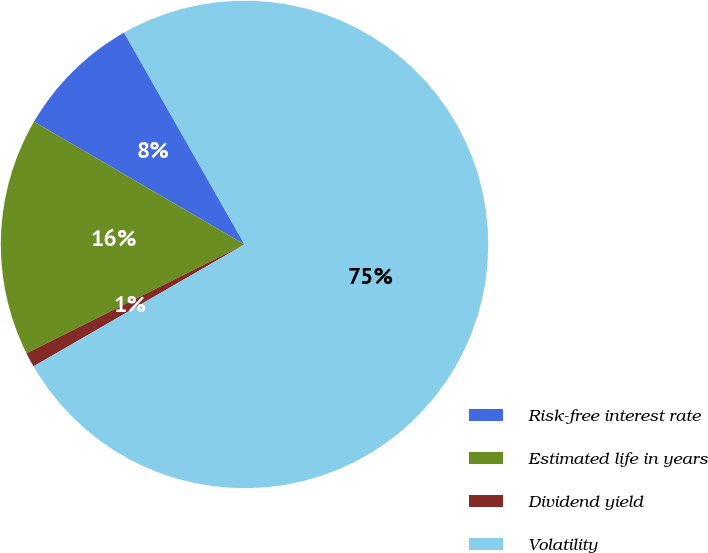Convert chart. <chart><loc_0><loc_0><loc_500><loc_500><pie_chart><fcel>Risk-free interest rate<fcel>Estimated life in years<fcel>Dividend yield<fcel>Volatility<nl><fcel>8.37%<fcel>15.77%<fcel>0.97%<fcel>74.9%<nl></chart> 